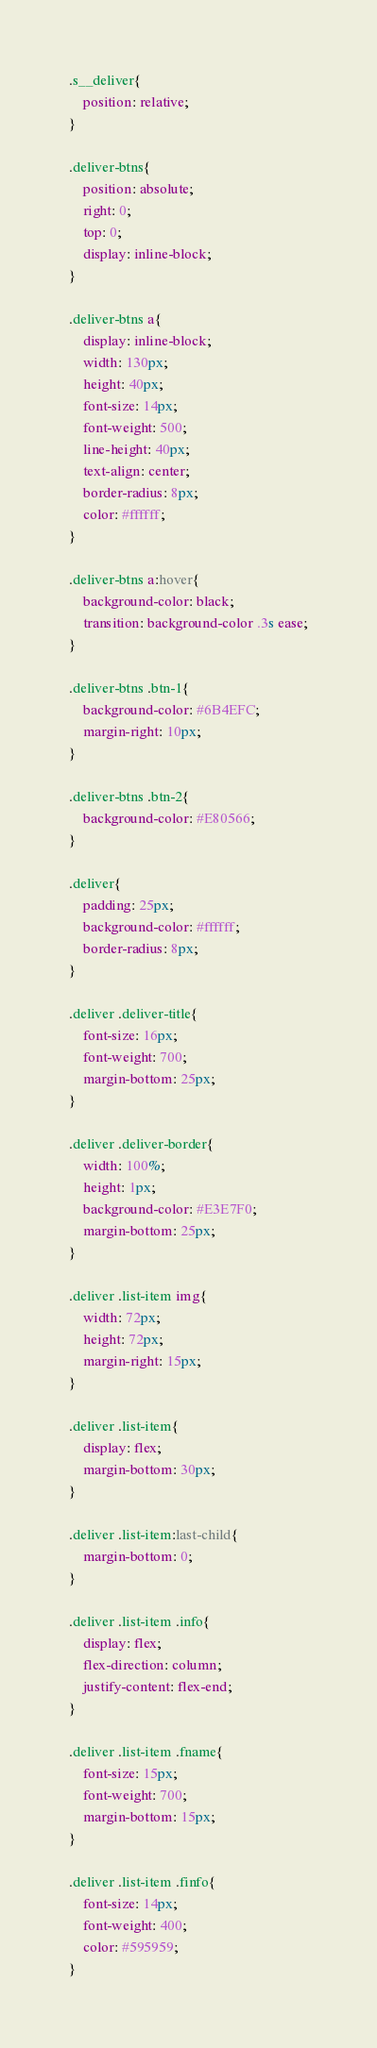<code> <loc_0><loc_0><loc_500><loc_500><_CSS_>.s__deliver{
    position: relative;
}

.deliver-btns{
    position: absolute;
    right: 0;
    top: 0;
    display: inline-block;
}

.deliver-btns a{
    display: inline-block;
    width: 130px;
    height: 40px;
    font-size: 14px;
    font-weight: 500;
    line-height: 40px;
    text-align: center;
    border-radius: 8px;
    color: #ffffff;
}

.deliver-btns a:hover{
    background-color: black;
    transition: background-color .3s ease;
}

.deliver-btns .btn-1{
    background-color: #6B4EFC;
    margin-right: 10px;
}

.deliver-btns .btn-2{
    background-color: #E80566;
}

.deliver{
    padding: 25px;
    background-color: #ffffff;
    border-radius: 8px;
}

.deliver .deliver-title{
    font-size: 16px;
    font-weight: 700;
    margin-bottom: 25px;
}

.deliver .deliver-border{
    width: 100%;
    height: 1px;
    background-color: #E3E7F0;
    margin-bottom: 25px;
}

.deliver .list-item img{
    width: 72px;
    height: 72px;
    margin-right: 15px;
}

.deliver .list-item{
    display: flex;
    margin-bottom: 30px;
}

.deliver .list-item:last-child{
    margin-bottom: 0;
}

.deliver .list-item .info{
    display: flex;
    flex-direction: column;
    justify-content: flex-end;
}

.deliver .list-item .fname{
    font-size: 15px;
    font-weight: 700;
    margin-bottom: 15px;
}

.deliver .list-item .finfo{
    font-size: 14px;
    font-weight: 400;
    color: #595959;
}</code> 